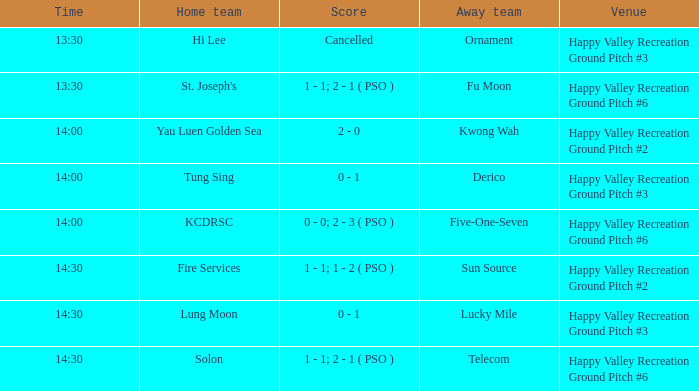What is the score of the match at happy valley recreation ground pitch #2 with a 14:30 time? 1 - 1; 1 - 2 ( PSO ). 